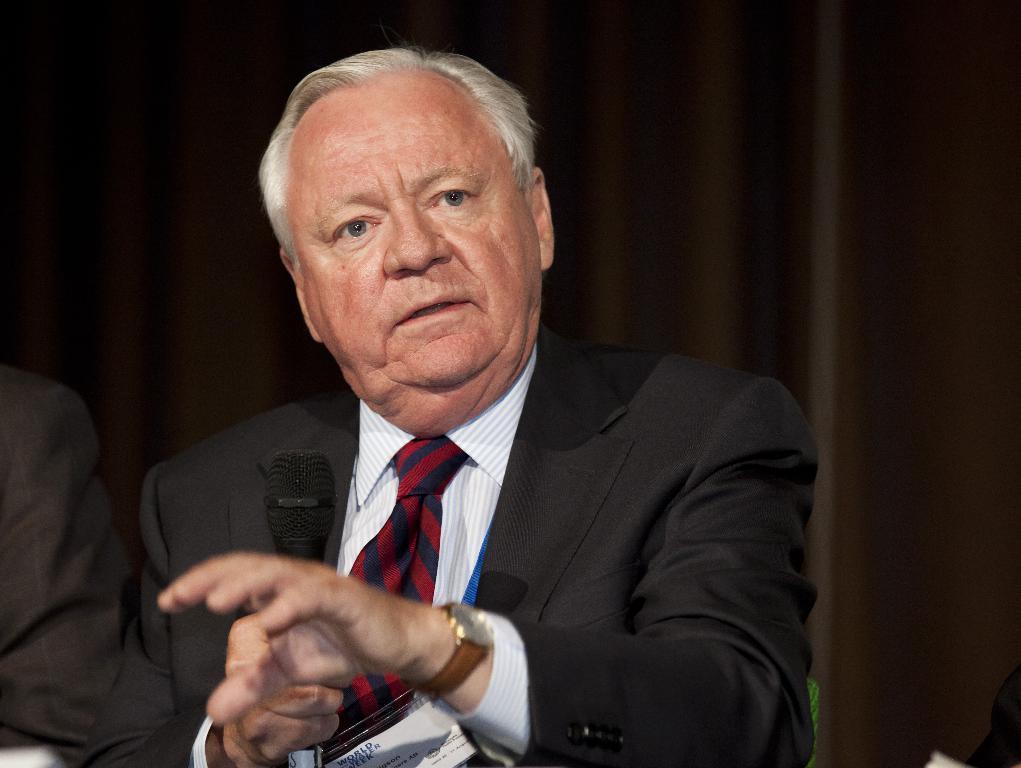In one or two sentences, can you explain what this image depicts? This picture describes about few people, in the middle of the image we can see a man, he is holding a microphone, and he wore a black color suit. 